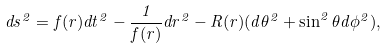Convert formula to latex. <formula><loc_0><loc_0><loc_500><loc_500>d s ^ { 2 } = f ( r ) d t ^ { 2 } - \frac { 1 } { f ( r ) } d r ^ { 2 } - R ( r ) ( d \theta ^ { 2 } + \sin ^ { 2 } \theta d \phi ^ { 2 } ) ,</formula> 